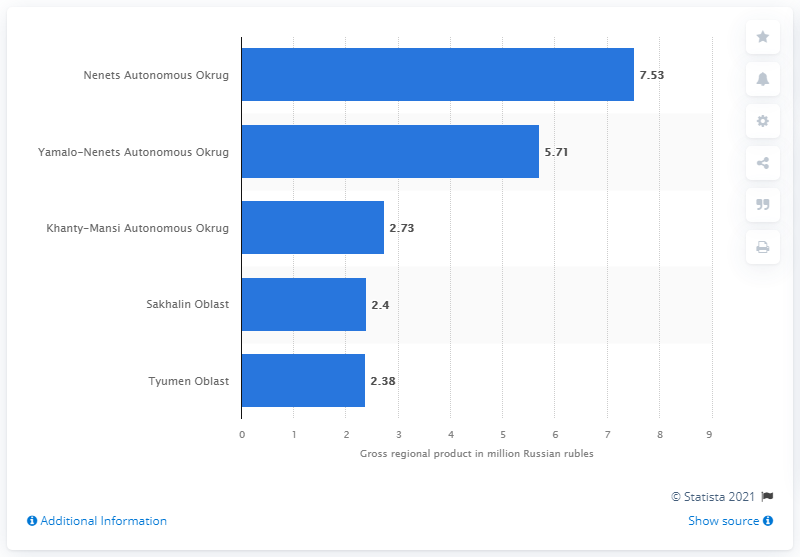Indicate a few pertinent items in this graphic. According to data, the Yamalo-Nenets Autonomous Okrug is the second richest region in Russia in terms of Gross Regional Product (GRP) per capita. In 2019, the Nenets Autonomous Okrug had the highest gross regional product per capita among all regions in Russia. The Nenets Autonomous Okrug has 7.53 rubles. The Yamalo-Nenets Autonomous Okrug produced 5.71 million Russian rubles over the course of a year. 